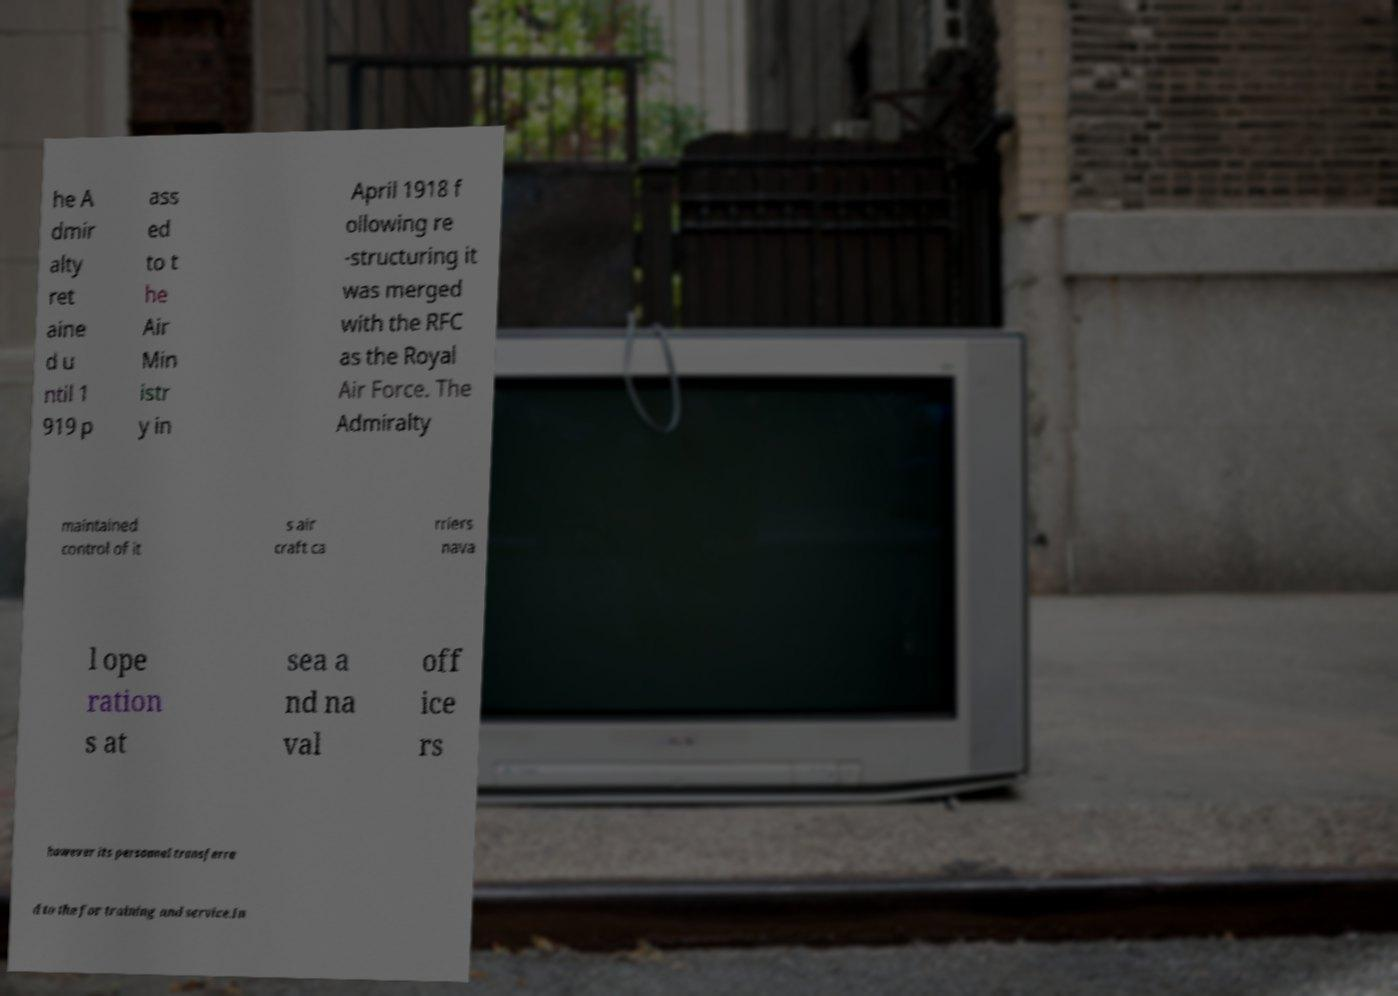Please read and relay the text visible in this image. What does it say? he A dmir alty ret aine d u ntil 1 919 p ass ed to t he Air Min istr y in April 1918 f ollowing re -structuring it was merged with the RFC as the Royal Air Force. The Admiralty maintained control of it s air craft ca rriers nava l ope ration s at sea a nd na val off ice rs however its personnel transferre d to the for training and service.In 